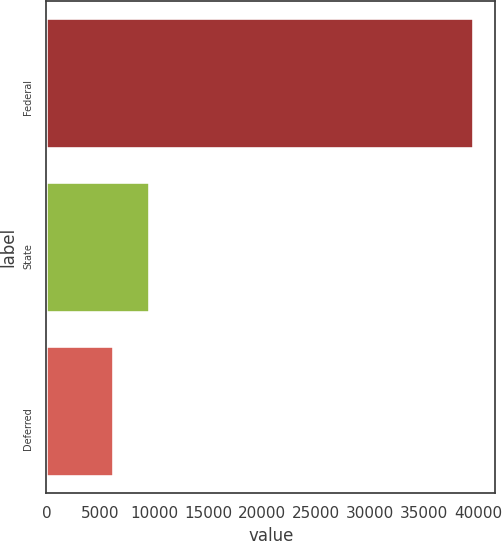Convert chart. <chart><loc_0><loc_0><loc_500><loc_500><bar_chart><fcel>Federal<fcel>State<fcel>Deferred<nl><fcel>39624<fcel>9569.4<fcel>6230<nl></chart> 